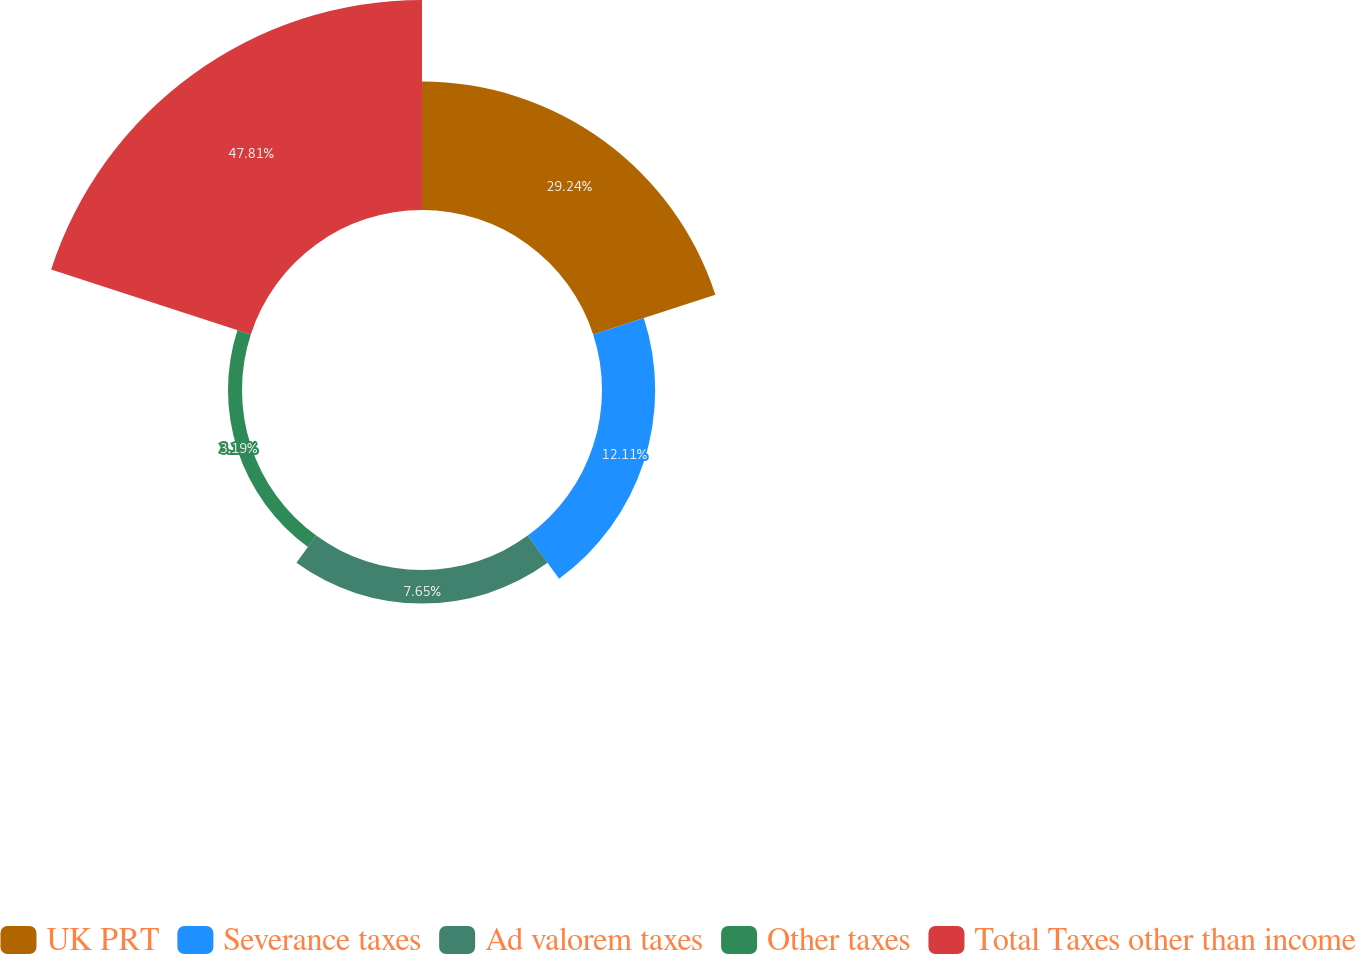<chart> <loc_0><loc_0><loc_500><loc_500><pie_chart><fcel>UK PRT<fcel>Severance taxes<fcel>Ad valorem taxes<fcel>Other taxes<fcel>Total Taxes other than income<nl><fcel>29.24%<fcel>12.11%<fcel>7.65%<fcel>3.19%<fcel>47.81%<nl></chart> 